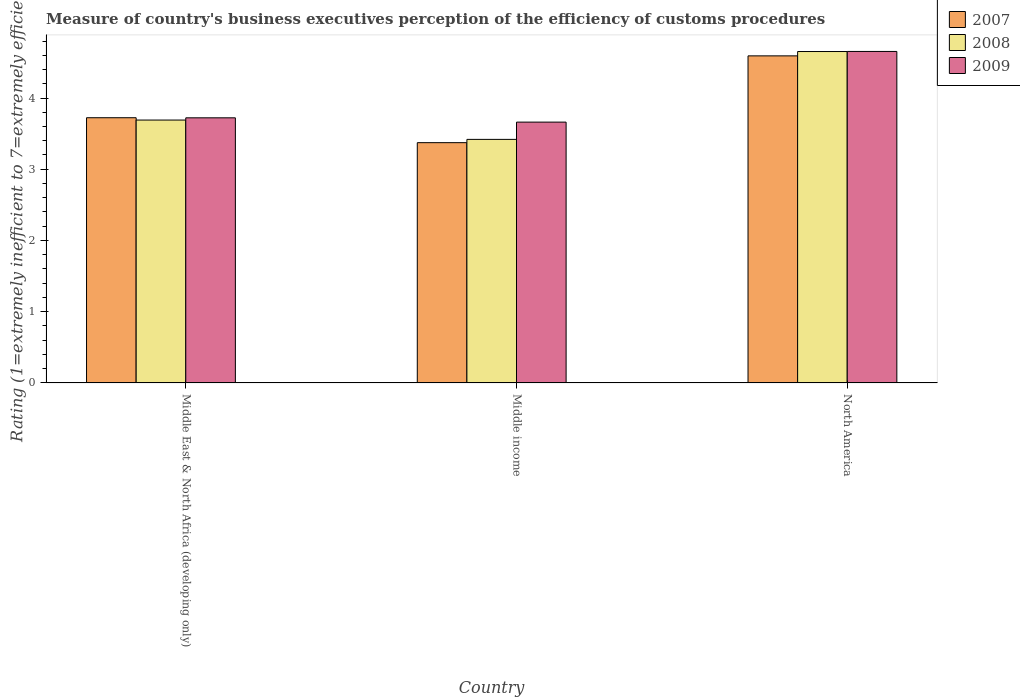How many groups of bars are there?
Make the answer very short. 3. Are the number of bars on each tick of the X-axis equal?
Offer a very short reply. Yes. How many bars are there on the 3rd tick from the left?
Your answer should be very brief. 3. What is the label of the 1st group of bars from the left?
Provide a short and direct response. Middle East & North Africa (developing only). In how many cases, is the number of bars for a given country not equal to the number of legend labels?
Your answer should be very brief. 0. What is the rating of the efficiency of customs procedure in 2008 in Middle income?
Make the answer very short. 3.42. Across all countries, what is the maximum rating of the efficiency of customs procedure in 2008?
Offer a terse response. 4.65. Across all countries, what is the minimum rating of the efficiency of customs procedure in 2008?
Your answer should be compact. 3.42. In which country was the rating of the efficiency of customs procedure in 2009 maximum?
Keep it short and to the point. North America. What is the total rating of the efficiency of customs procedure in 2007 in the graph?
Provide a short and direct response. 11.69. What is the difference between the rating of the efficiency of customs procedure in 2008 in Middle East & North Africa (developing only) and that in Middle income?
Keep it short and to the point. 0.27. What is the difference between the rating of the efficiency of customs procedure in 2009 in North America and the rating of the efficiency of customs procedure in 2008 in Middle income?
Offer a very short reply. 1.23. What is the average rating of the efficiency of customs procedure in 2008 per country?
Your answer should be very brief. 3.92. What is the difference between the rating of the efficiency of customs procedure of/in 2008 and rating of the efficiency of customs procedure of/in 2007 in Middle income?
Provide a succinct answer. 0.05. In how many countries, is the rating of the efficiency of customs procedure in 2008 greater than 3.8?
Make the answer very short. 1. What is the ratio of the rating of the efficiency of customs procedure in 2009 in Middle income to that in North America?
Your answer should be compact. 0.79. Is the rating of the efficiency of customs procedure in 2008 in Middle East & North Africa (developing only) less than that in North America?
Offer a terse response. Yes. Is the difference between the rating of the efficiency of customs procedure in 2008 in Middle East & North Africa (developing only) and Middle income greater than the difference between the rating of the efficiency of customs procedure in 2007 in Middle East & North Africa (developing only) and Middle income?
Provide a short and direct response. No. What is the difference between the highest and the second highest rating of the efficiency of customs procedure in 2007?
Give a very brief answer. -0.35. What is the difference between the highest and the lowest rating of the efficiency of customs procedure in 2009?
Keep it short and to the point. 0.99. What does the 1st bar from the left in Middle East & North Africa (developing only) represents?
Offer a very short reply. 2007. Is it the case that in every country, the sum of the rating of the efficiency of customs procedure in 2007 and rating of the efficiency of customs procedure in 2008 is greater than the rating of the efficiency of customs procedure in 2009?
Provide a succinct answer. Yes. Are all the bars in the graph horizontal?
Offer a very short reply. No. How many countries are there in the graph?
Offer a very short reply. 3. What is the difference between two consecutive major ticks on the Y-axis?
Your answer should be compact. 1. Does the graph contain any zero values?
Provide a succinct answer. No. How many legend labels are there?
Ensure brevity in your answer.  3. What is the title of the graph?
Your answer should be very brief. Measure of country's business executives perception of the efficiency of customs procedures. Does "1964" appear as one of the legend labels in the graph?
Give a very brief answer. No. What is the label or title of the Y-axis?
Make the answer very short. Rating (1=extremely inefficient to 7=extremely efficient). What is the Rating (1=extremely inefficient to 7=extremely efficient) in 2007 in Middle East & North Africa (developing only)?
Your answer should be very brief. 3.72. What is the Rating (1=extremely inefficient to 7=extremely efficient) in 2008 in Middle East & North Africa (developing only)?
Give a very brief answer. 3.69. What is the Rating (1=extremely inefficient to 7=extremely efficient) in 2009 in Middle East & North Africa (developing only)?
Offer a terse response. 3.72. What is the Rating (1=extremely inefficient to 7=extremely efficient) of 2007 in Middle income?
Your answer should be very brief. 3.37. What is the Rating (1=extremely inefficient to 7=extremely efficient) of 2008 in Middle income?
Make the answer very short. 3.42. What is the Rating (1=extremely inefficient to 7=extremely efficient) in 2009 in Middle income?
Make the answer very short. 3.66. What is the Rating (1=extremely inefficient to 7=extremely efficient) in 2007 in North America?
Offer a very short reply. 4.59. What is the Rating (1=extremely inefficient to 7=extremely efficient) in 2008 in North America?
Give a very brief answer. 4.65. What is the Rating (1=extremely inefficient to 7=extremely efficient) in 2009 in North America?
Provide a succinct answer. 4.65. Across all countries, what is the maximum Rating (1=extremely inefficient to 7=extremely efficient) of 2007?
Offer a very short reply. 4.59. Across all countries, what is the maximum Rating (1=extremely inefficient to 7=extremely efficient) of 2008?
Ensure brevity in your answer.  4.65. Across all countries, what is the maximum Rating (1=extremely inefficient to 7=extremely efficient) of 2009?
Offer a terse response. 4.65. Across all countries, what is the minimum Rating (1=extremely inefficient to 7=extremely efficient) of 2007?
Provide a succinct answer. 3.37. Across all countries, what is the minimum Rating (1=extremely inefficient to 7=extremely efficient) of 2008?
Provide a succinct answer. 3.42. Across all countries, what is the minimum Rating (1=extremely inefficient to 7=extremely efficient) of 2009?
Offer a very short reply. 3.66. What is the total Rating (1=extremely inefficient to 7=extremely efficient) in 2007 in the graph?
Offer a terse response. 11.69. What is the total Rating (1=extremely inefficient to 7=extremely efficient) of 2008 in the graph?
Provide a succinct answer. 11.76. What is the total Rating (1=extremely inefficient to 7=extremely efficient) of 2009 in the graph?
Your response must be concise. 12.04. What is the difference between the Rating (1=extremely inefficient to 7=extremely efficient) in 2008 in Middle East & North Africa (developing only) and that in Middle income?
Make the answer very short. 0.27. What is the difference between the Rating (1=extremely inefficient to 7=extremely efficient) of 2009 in Middle East & North Africa (developing only) and that in Middle income?
Make the answer very short. 0.06. What is the difference between the Rating (1=extremely inefficient to 7=extremely efficient) of 2007 in Middle East & North Africa (developing only) and that in North America?
Provide a succinct answer. -0.87. What is the difference between the Rating (1=extremely inefficient to 7=extremely efficient) in 2008 in Middle East & North Africa (developing only) and that in North America?
Make the answer very short. -0.96. What is the difference between the Rating (1=extremely inefficient to 7=extremely efficient) of 2009 in Middle East & North Africa (developing only) and that in North America?
Your answer should be very brief. -0.93. What is the difference between the Rating (1=extremely inefficient to 7=extremely efficient) of 2007 in Middle income and that in North America?
Ensure brevity in your answer.  -1.22. What is the difference between the Rating (1=extremely inefficient to 7=extremely efficient) in 2008 in Middle income and that in North America?
Give a very brief answer. -1.23. What is the difference between the Rating (1=extremely inefficient to 7=extremely efficient) of 2009 in Middle income and that in North America?
Offer a terse response. -0.99. What is the difference between the Rating (1=extremely inefficient to 7=extremely efficient) of 2007 in Middle East & North Africa (developing only) and the Rating (1=extremely inefficient to 7=extremely efficient) of 2008 in Middle income?
Offer a terse response. 0.3. What is the difference between the Rating (1=extremely inefficient to 7=extremely efficient) in 2007 in Middle East & North Africa (developing only) and the Rating (1=extremely inefficient to 7=extremely efficient) in 2009 in Middle income?
Make the answer very short. 0.06. What is the difference between the Rating (1=extremely inefficient to 7=extremely efficient) of 2008 in Middle East & North Africa (developing only) and the Rating (1=extremely inefficient to 7=extremely efficient) of 2009 in Middle income?
Your answer should be compact. 0.03. What is the difference between the Rating (1=extremely inefficient to 7=extremely efficient) of 2007 in Middle East & North Africa (developing only) and the Rating (1=extremely inefficient to 7=extremely efficient) of 2008 in North America?
Provide a short and direct response. -0.93. What is the difference between the Rating (1=extremely inefficient to 7=extremely efficient) in 2007 in Middle East & North Africa (developing only) and the Rating (1=extremely inefficient to 7=extremely efficient) in 2009 in North America?
Provide a short and direct response. -0.93. What is the difference between the Rating (1=extremely inefficient to 7=extremely efficient) in 2008 in Middle East & North Africa (developing only) and the Rating (1=extremely inefficient to 7=extremely efficient) in 2009 in North America?
Give a very brief answer. -0.96. What is the difference between the Rating (1=extremely inefficient to 7=extremely efficient) of 2007 in Middle income and the Rating (1=extremely inefficient to 7=extremely efficient) of 2008 in North America?
Ensure brevity in your answer.  -1.28. What is the difference between the Rating (1=extremely inefficient to 7=extremely efficient) of 2007 in Middle income and the Rating (1=extremely inefficient to 7=extremely efficient) of 2009 in North America?
Ensure brevity in your answer.  -1.28. What is the difference between the Rating (1=extremely inefficient to 7=extremely efficient) in 2008 in Middle income and the Rating (1=extremely inefficient to 7=extremely efficient) in 2009 in North America?
Provide a succinct answer. -1.23. What is the average Rating (1=extremely inefficient to 7=extremely efficient) in 2007 per country?
Offer a terse response. 3.9. What is the average Rating (1=extremely inefficient to 7=extremely efficient) in 2008 per country?
Ensure brevity in your answer.  3.92. What is the average Rating (1=extremely inefficient to 7=extremely efficient) in 2009 per country?
Give a very brief answer. 4.01. What is the difference between the Rating (1=extremely inefficient to 7=extremely efficient) in 2007 and Rating (1=extremely inefficient to 7=extremely efficient) in 2008 in Middle East & North Africa (developing only)?
Offer a very short reply. 0.03. What is the difference between the Rating (1=extremely inefficient to 7=extremely efficient) in 2007 and Rating (1=extremely inefficient to 7=extremely efficient) in 2009 in Middle East & North Africa (developing only)?
Ensure brevity in your answer.  0. What is the difference between the Rating (1=extremely inefficient to 7=extremely efficient) in 2008 and Rating (1=extremely inefficient to 7=extremely efficient) in 2009 in Middle East & North Africa (developing only)?
Give a very brief answer. -0.03. What is the difference between the Rating (1=extremely inefficient to 7=extremely efficient) in 2007 and Rating (1=extremely inefficient to 7=extremely efficient) in 2008 in Middle income?
Make the answer very short. -0.05. What is the difference between the Rating (1=extremely inefficient to 7=extremely efficient) in 2007 and Rating (1=extremely inefficient to 7=extremely efficient) in 2009 in Middle income?
Offer a very short reply. -0.29. What is the difference between the Rating (1=extremely inefficient to 7=extremely efficient) in 2008 and Rating (1=extremely inefficient to 7=extremely efficient) in 2009 in Middle income?
Make the answer very short. -0.24. What is the difference between the Rating (1=extremely inefficient to 7=extremely efficient) of 2007 and Rating (1=extremely inefficient to 7=extremely efficient) of 2008 in North America?
Offer a very short reply. -0.06. What is the difference between the Rating (1=extremely inefficient to 7=extremely efficient) of 2007 and Rating (1=extremely inefficient to 7=extremely efficient) of 2009 in North America?
Make the answer very short. -0.06. What is the difference between the Rating (1=extremely inefficient to 7=extremely efficient) of 2008 and Rating (1=extremely inefficient to 7=extremely efficient) of 2009 in North America?
Provide a short and direct response. -0. What is the ratio of the Rating (1=extremely inefficient to 7=extremely efficient) in 2007 in Middle East & North Africa (developing only) to that in Middle income?
Offer a very short reply. 1.1. What is the ratio of the Rating (1=extremely inefficient to 7=extremely efficient) in 2008 in Middle East & North Africa (developing only) to that in Middle income?
Your answer should be very brief. 1.08. What is the ratio of the Rating (1=extremely inefficient to 7=extremely efficient) in 2009 in Middle East & North Africa (developing only) to that in Middle income?
Keep it short and to the point. 1.02. What is the ratio of the Rating (1=extremely inefficient to 7=extremely efficient) in 2007 in Middle East & North Africa (developing only) to that in North America?
Provide a succinct answer. 0.81. What is the ratio of the Rating (1=extremely inefficient to 7=extremely efficient) of 2008 in Middle East & North Africa (developing only) to that in North America?
Offer a terse response. 0.79. What is the ratio of the Rating (1=extremely inefficient to 7=extremely efficient) of 2009 in Middle East & North Africa (developing only) to that in North America?
Your answer should be compact. 0.8. What is the ratio of the Rating (1=extremely inefficient to 7=extremely efficient) in 2007 in Middle income to that in North America?
Make the answer very short. 0.73. What is the ratio of the Rating (1=extremely inefficient to 7=extremely efficient) in 2008 in Middle income to that in North America?
Offer a very short reply. 0.73. What is the ratio of the Rating (1=extremely inefficient to 7=extremely efficient) in 2009 in Middle income to that in North America?
Keep it short and to the point. 0.79. What is the difference between the highest and the second highest Rating (1=extremely inefficient to 7=extremely efficient) in 2007?
Your answer should be compact. 0.87. What is the difference between the highest and the second highest Rating (1=extremely inefficient to 7=extremely efficient) in 2008?
Provide a short and direct response. 0.96. What is the difference between the highest and the second highest Rating (1=extremely inefficient to 7=extremely efficient) in 2009?
Keep it short and to the point. 0.93. What is the difference between the highest and the lowest Rating (1=extremely inefficient to 7=extremely efficient) in 2007?
Provide a short and direct response. 1.22. What is the difference between the highest and the lowest Rating (1=extremely inefficient to 7=extremely efficient) in 2008?
Offer a very short reply. 1.23. What is the difference between the highest and the lowest Rating (1=extremely inefficient to 7=extremely efficient) of 2009?
Offer a very short reply. 0.99. 